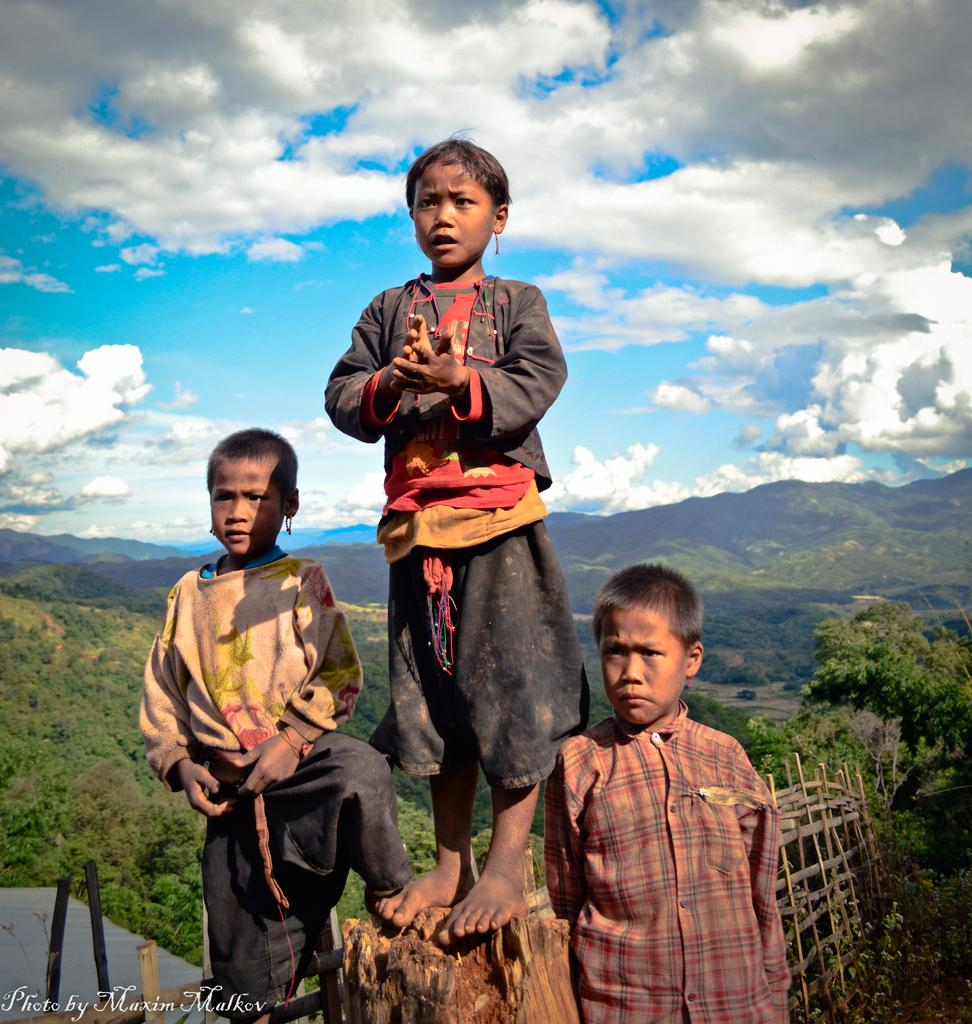How many people are in the image? There are three people standing in the image. What can be seen in the background of the image? There are trees and hills in the background of the image. What is visible in the sky in the image? The sky is visible in the image, and clouds are present. What type of paint is being used by the crow in the image? There is no crow present in the image, and therefore no paint or painting activity can be observed. 